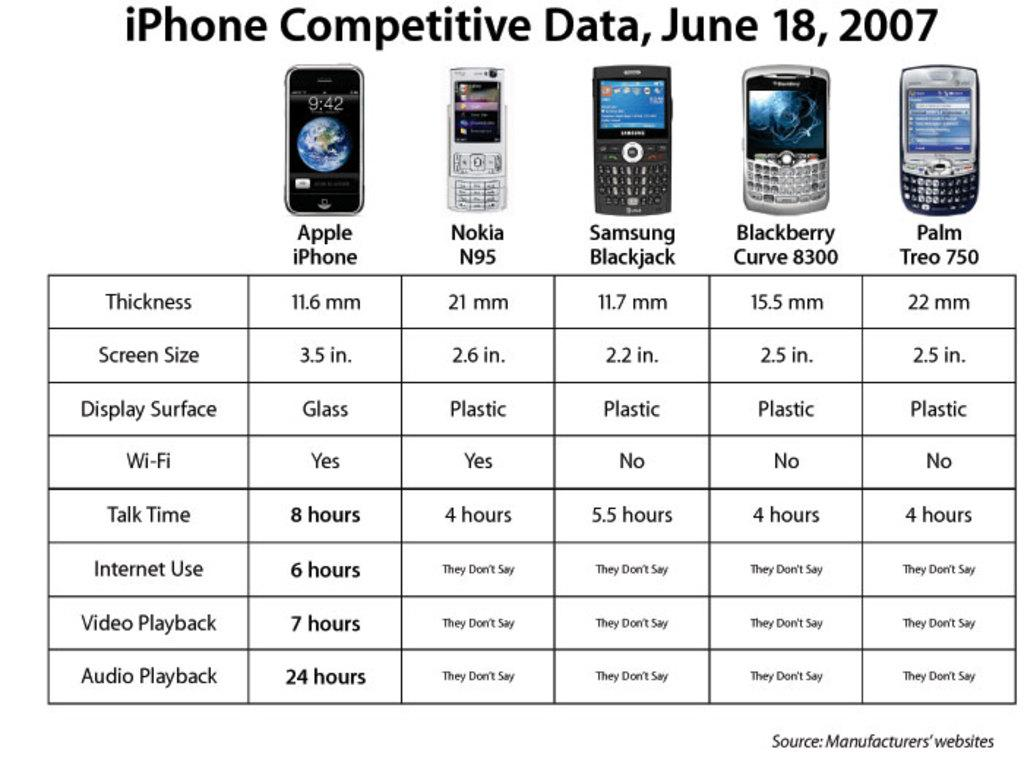<image>
Share a concise interpretation of the image provided. An infograqphic comparing iPhones to other phones manufactured in 2007. 